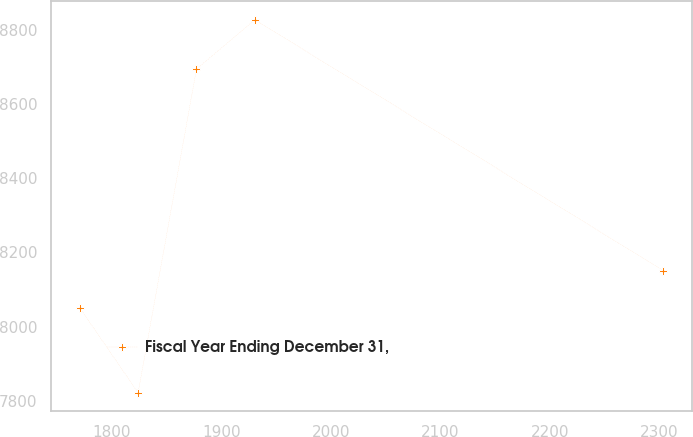Convert chart to OTSL. <chart><loc_0><loc_0><loc_500><loc_500><line_chart><ecel><fcel>Fiscal Year Ending December 31,<nl><fcel>1770.86<fcel>8050.49<nl><fcel>1824.12<fcel>7821.26<nl><fcel>1877.38<fcel>8694.81<nl><fcel>1930.64<fcel>8827.6<nl><fcel>2303.44<fcel>8151.12<nl></chart> 